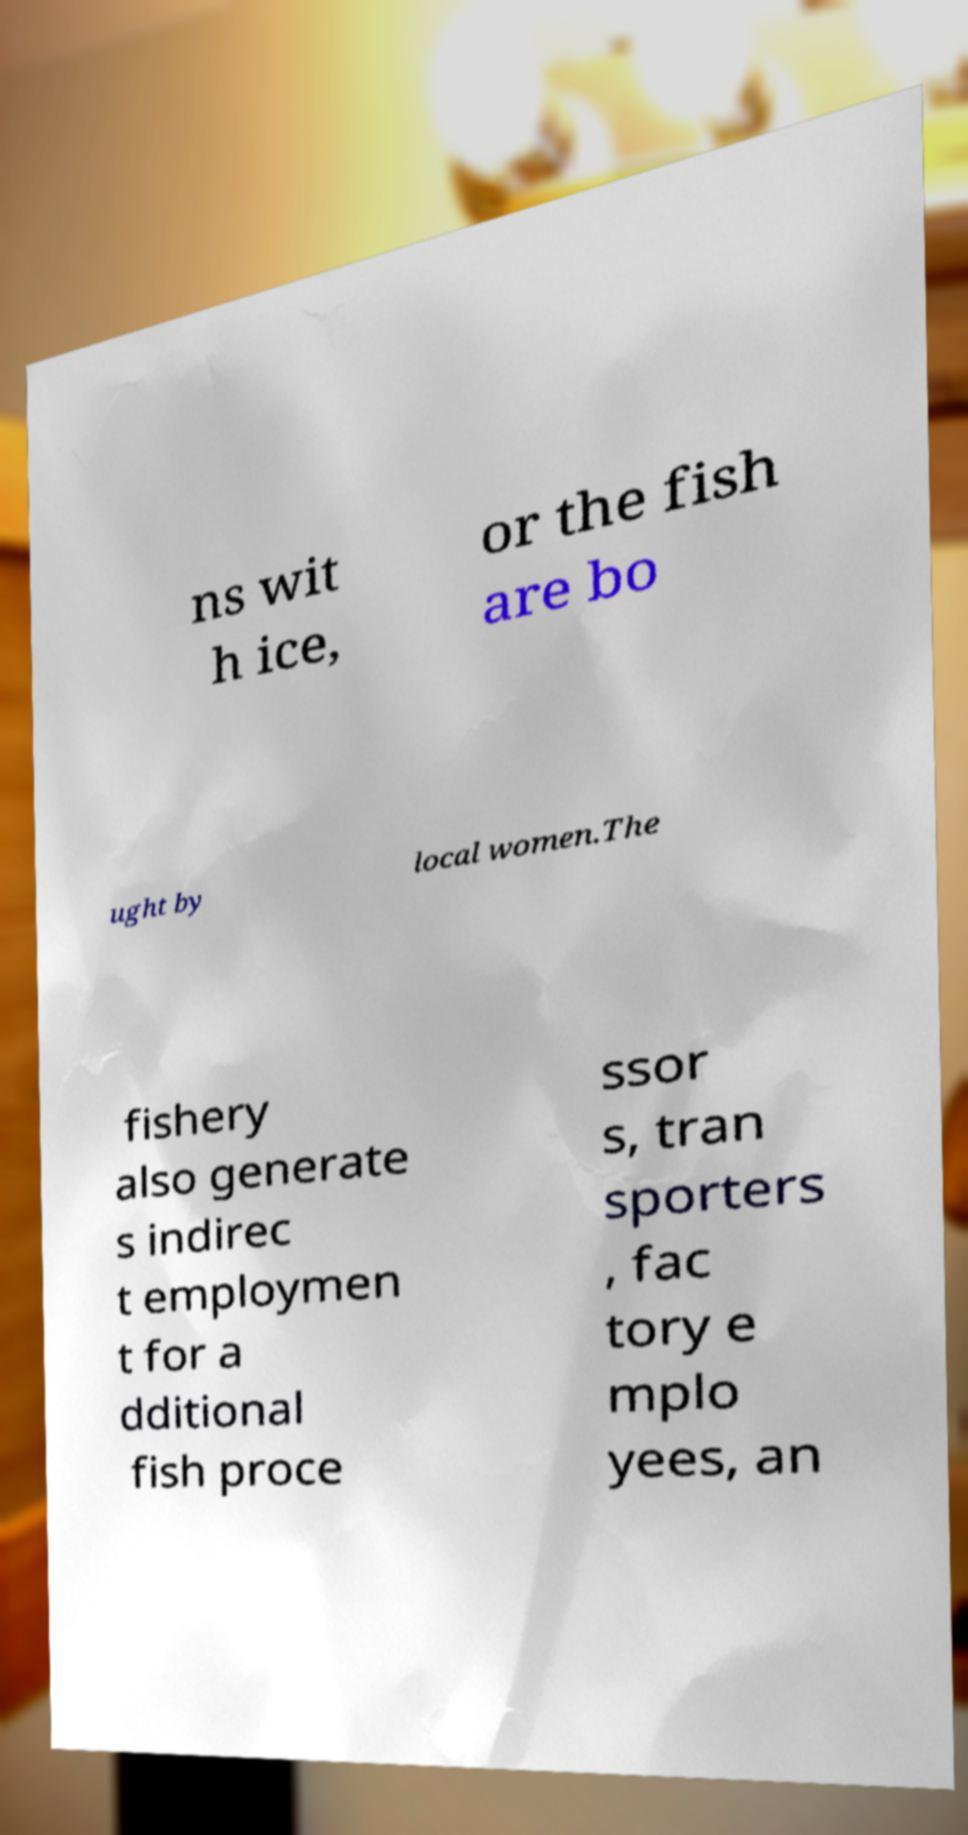Please identify and transcribe the text found in this image. ns wit h ice, or the fish are bo ught by local women.The fishery also generate s indirec t employmen t for a dditional fish proce ssor s, tran sporters , fac tory e mplo yees, an 